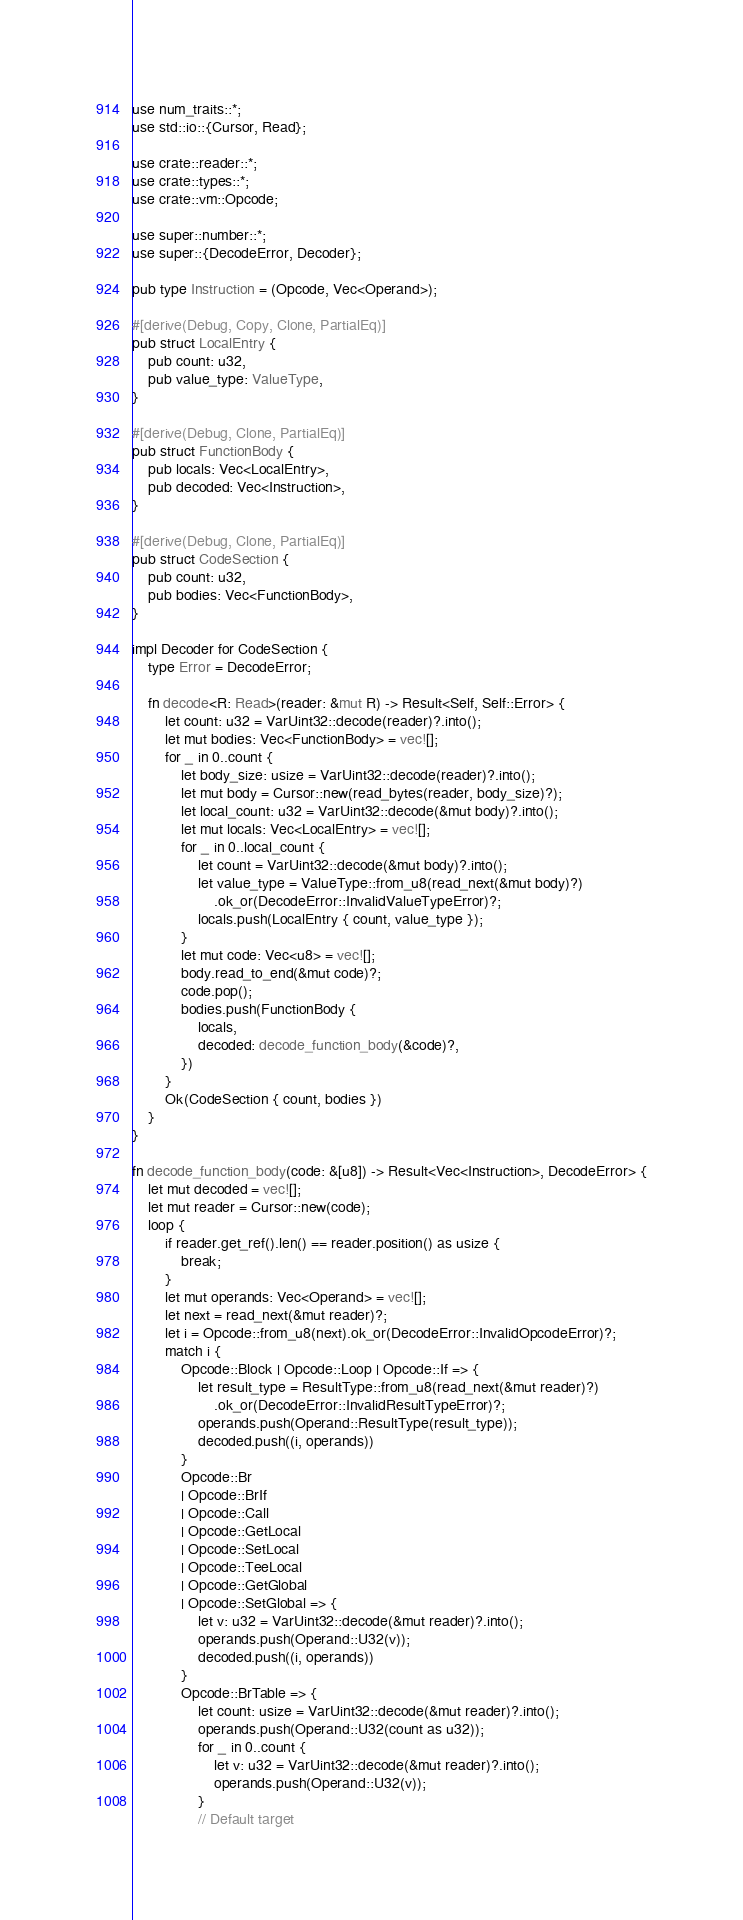Convert code to text. <code><loc_0><loc_0><loc_500><loc_500><_Rust_>use num_traits::*;
use std::io::{Cursor, Read};

use crate::reader::*;
use crate::types::*;
use crate::vm::Opcode;

use super::number::*;
use super::{DecodeError, Decoder};

pub type Instruction = (Opcode, Vec<Operand>);

#[derive(Debug, Copy, Clone, PartialEq)]
pub struct LocalEntry {
    pub count: u32,
    pub value_type: ValueType,
}

#[derive(Debug, Clone, PartialEq)]
pub struct FunctionBody {
    pub locals: Vec<LocalEntry>,
    pub decoded: Vec<Instruction>,
}

#[derive(Debug, Clone, PartialEq)]
pub struct CodeSection {
    pub count: u32,
    pub bodies: Vec<FunctionBody>,
}

impl Decoder for CodeSection {
    type Error = DecodeError;

    fn decode<R: Read>(reader: &mut R) -> Result<Self, Self::Error> {
        let count: u32 = VarUint32::decode(reader)?.into();
        let mut bodies: Vec<FunctionBody> = vec![];
        for _ in 0..count {
            let body_size: usize = VarUint32::decode(reader)?.into();
            let mut body = Cursor::new(read_bytes(reader, body_size)?);
            let local_count: u32 = VarUint32::decode(&mut body)?.into();
            let mut locals: Vec<LocalEntry> = vec![];
            for _ in 0..local_count {
                let count = VarUint32::decode(&mut body)?.into();
                let value_type = ValueType::from_u8(read_next(&mut body)?)
                    .ok_or(DecodeError::InvalidValueTypeError)?;
                locals.push(LocalEntry { count, value_type });
            }
            let mut code: Vec<u8> = vec![];
            body.read_to_end(&mut code)?;
            code.pop();
            bodies.push(FunctionBody {
                locals,
                decoded: decode_function_body(&code)?,
            })
        }
        Ok(CodeSection { count, bodies })
    }
}

fn decode_function_body(code: &[u8]) -> Result<Vec<Instruction>, DecodeError> {
    let mut decoded = vec![];
    let mut reader = Cursor::new(code);
    loop {
        if reader.get_ref().len() == reader.position() as usize {
            break;
        }
        let mut operands: Vec<Operand> = vec![];
        let next = read_next(&mut reader)?;
        let i = Opcode::from_u8(next).ok_or(DecodeError::InvalidOpcodeError)?;
        match i {
            Opcode::Block | Opcode::Loop | Opcode::If => {
                let result_type = ResultType::from_u8(read_next(&mut reader)?)
                    .ok_or(DecodeError::InvalidResultTypeError)?;
                operands.push(Operand::ResultType(result_type));
                decoded.push((i, operands))
            }
            Opcode::Br
            | Opcode::BrIf
            | Opcode::Call
            | Opcode::GetLocal
            | Opcode::SetLocal
            | Opcode::TeeLocal
            | Opcode::GetGlobal
            | Opcode::SetGlobal => {
                let v: u32 = VarUint32::decode(&mut reader)?.into();
                operands.push(Operand::U32(v));
                decoded.push((i, operands))
            }
            Opcode::BrTable => {
                let count: usize = VarUint32::decode(&mut reader)?.into();
                operands.push(Operand::U32(count as u32));
                for _ in 0..count {
                    let v: u32 = VarUint32::decode(&mut reader)?.into();
                    operands.push(Operand::U32(v));
                }
                // Default target</code> 